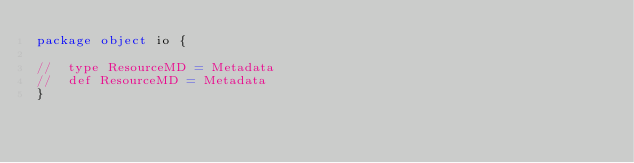Convert code to text. <code><loc_0><loc_0><loc_500><loc_500><_Scala_>package object io {

//  type ResourceMD = Metadata
//  def ResourceMD = Metadata
}
</code> 